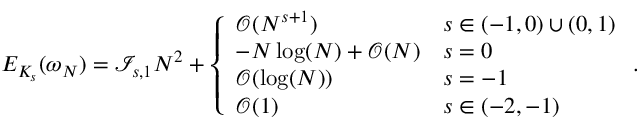<formula> <loc_0><loc_0><loc_500><loc_500>E _ { K _ { s } } ( \omega _ { N } ) = \mathcal { I } _ { s , 1 } N ^ { 2 } + \left \{ \begin{array} { l l } { \mathcal { O } ( N ^ { s + 1 } ) } & { s \in ( - 1 , 0 ) \cup ( 0 , 1 ) } \\ { - N \log ( N ) + \mathcal { O } ( N ) } & { s = 0 } \\ { \mathcal { O } ( \log ( N ) ) } & { s = - 1 } \\ { \mathcal { O } ( 1 ) } & { s \in ( - 2 , - 1 ) } \end{array} .</formula> 